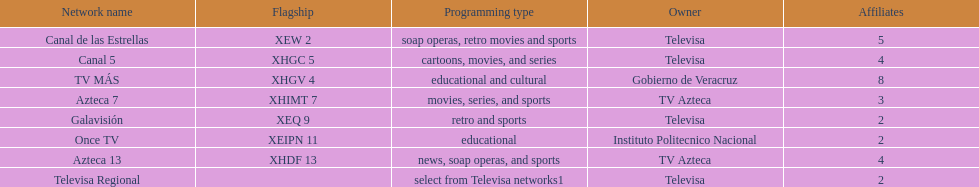How many networks have more partners than canal de las estrellas? 1. 